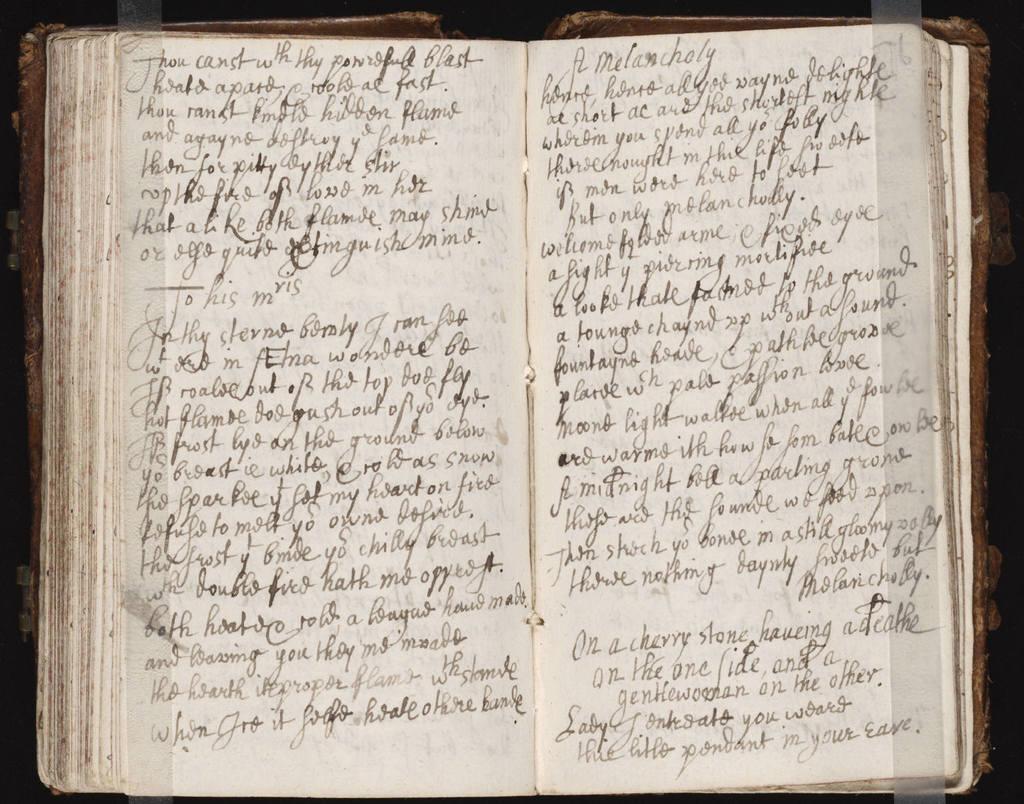What are the 2 words at the top right page?
Give a very brief answer. A melancholy. 